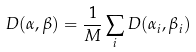Convert formula to latex. <formula><loc_0><loc_0><loc_500><loc_500>D ( \alpha , \beta ) = \frac { 1 } { M } \sum _ { i } D ( \alpha _ { i } , \beta _ { i } )</formula> 